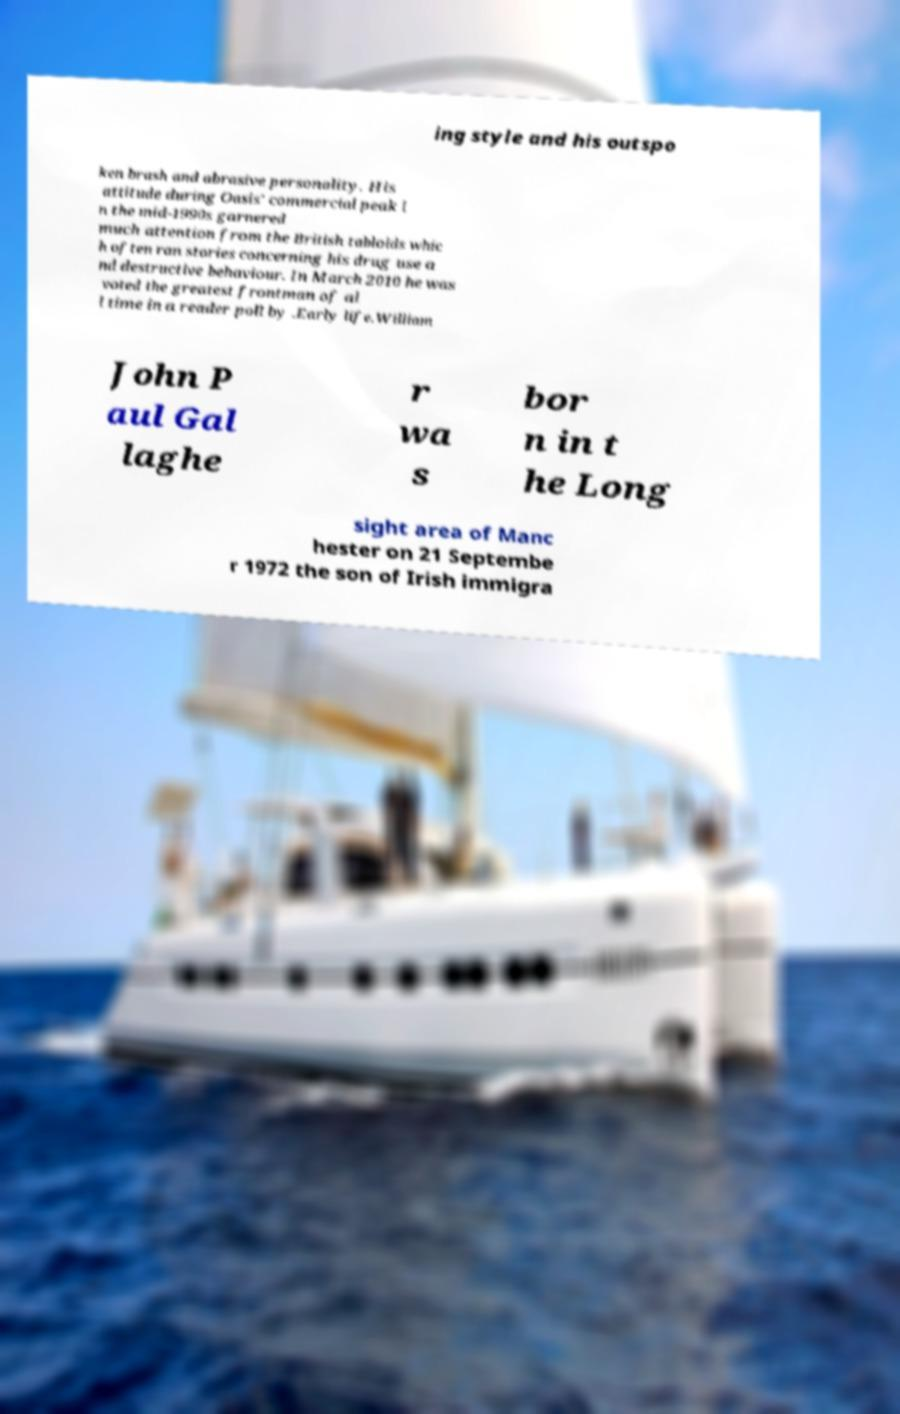There's text embedded in this image that I need extracted. Can you transcribe it verbatim? ing style and his outspo ken brash and abrasive personality. His attitude during Oasis' commercial peak i n the mid-1990s garnered much attention from the British tabloids whic h often ran stories concerning his drug use a nd destructive behaviour. In March 2010 he was voted the greatest frontman of al l time in a reader poll by .Early life.William John P aul Gal laghe r wa s bor n in t he Long sight area of Manc hester on 21 Septembe r 1972 the son of Irish immigra 